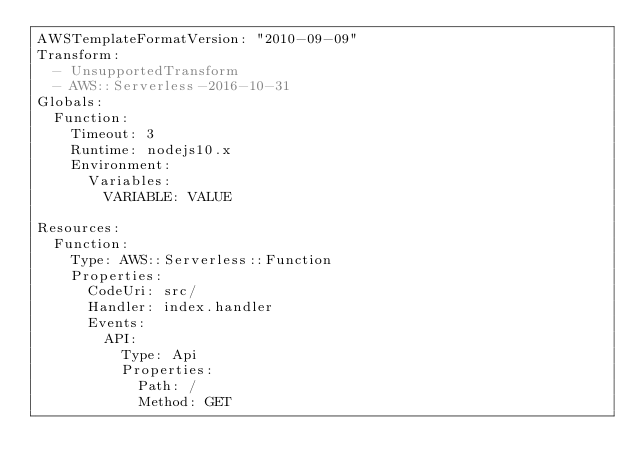<code> <loc_0><loc_0><loc_500><loc_500><_YAML_>AWSTemplateFormatVersion: "2010-09-09"
Transform:
  - UnsupportedTransform
  - AWS::Serverless-2016-10-31
Globals:
  Function:
    Timeout: 3
    Runtime: nodejs10.x
    Environment:
      Variables:
        VARIABLE: VALUE

Resources:
  Function:
    Type: AWS::Serverless::Function
    Properties:
      CodeUri: src/
      Handler: index.handler
      Events:
        API:
          Type: Api
          Properties:
            Path: /
            Method: GET
</code> 